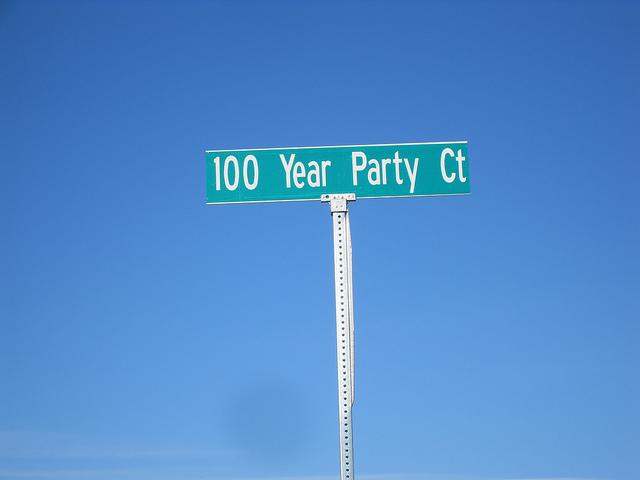What does the abbreviation on the sign stand for?
Quick response, please. Court. What is the name of the street?
Write a very short answer. 100 year party ct. Are there clouds in the sky?
Be succinct. No. What avenue is this?
Give a very brief answer. 100 year party ct. What is the name on the top street sign?
Write a very short answer. 100 year party ct. Is the sky clear?
Be succinct. Yes. What is the street name?
Concise answer only. 100 year party ct. What does the sign say?
Short answer required. 100 year party ct. Are there any clouds in the sky?
Write a very short answer. No. What is in the sky?
Keep it brief. Nothing. Is it a clear day out?
Write a very short answer. Yes. Is it day or night time?
Keep it brief. Day. Is the street name next to the lights?
Keep it brief. No. Is this an avenue?
Keep it brief. No. Is there a temple behind the sign?
Give a very brief answer. No. What is the sign say?
Short answer required. 100 year party ct. How many years?
Concise answer only. 100. What street is this?
Keep it brief. 100 year party ct. What street is it?
Short answer required. 100 year party ct. Is this road famous?
Answer briefly. No. What color is the sign?
Answer briefly. Green. What type of cloud is behind the sign?
Quick response, please. None. What is the name of the street on the sign?
Give a very brief answer. 100 year party ct. What kind of sign is this?
Quick response, please. Street sign. 